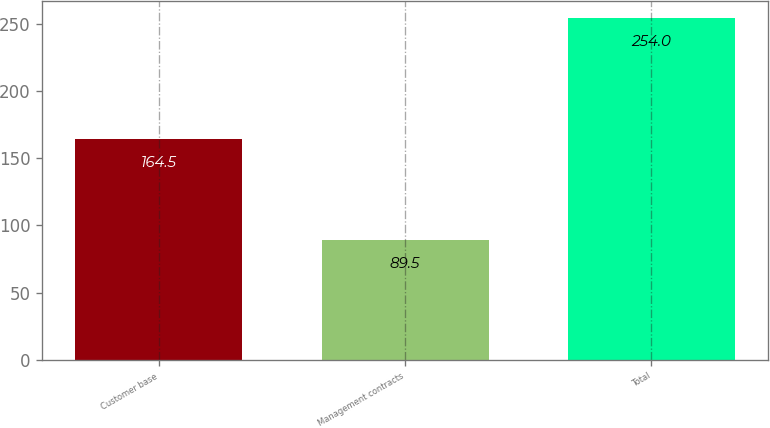Convert chart to OTSL. <chart><loc_0><loc_0><loc_500><loc_500><bar_chart><fcel>Customer base<fcel>Management contracts<fcel>Total<nl><fcel>164.5<fcel>89.5<fcel>254<nl></chart> 